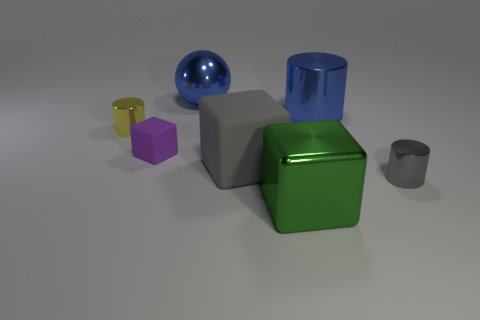Subtract all gray blocks. How many blocks are left? 2 Add 3 big red matte cubes. How many objects exist? 10 Subtract 1 blocks. How many blocks are left? 2 Subtract all purple cylinders. Subtract all red blocks. How many cylinders are left? 3 Subtract all blue balls. How many brown cylinders are left? 0 Subtract all big yellow metallic blocks. Subtract all large green objects. How many objects are left? 6 Add 4 tiny blocks. How many tiny blocks are left? 5 Add 7 gray rubber things. How many gray rubber things exist? 8 Subtract all gray cylinders. How many cylinders are left? 2 Subtract 0 brown blocks. How many objects are left? 7 